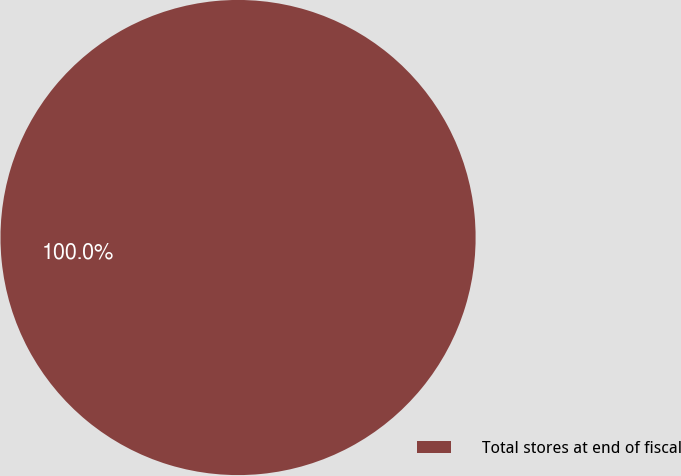Convert chart. <chart><loc_0><loc_0><loc_500><loc_500><pie_chart><fcel>Total stores at end of fiscal<nl><fcel>100.0%<nl></chart> 